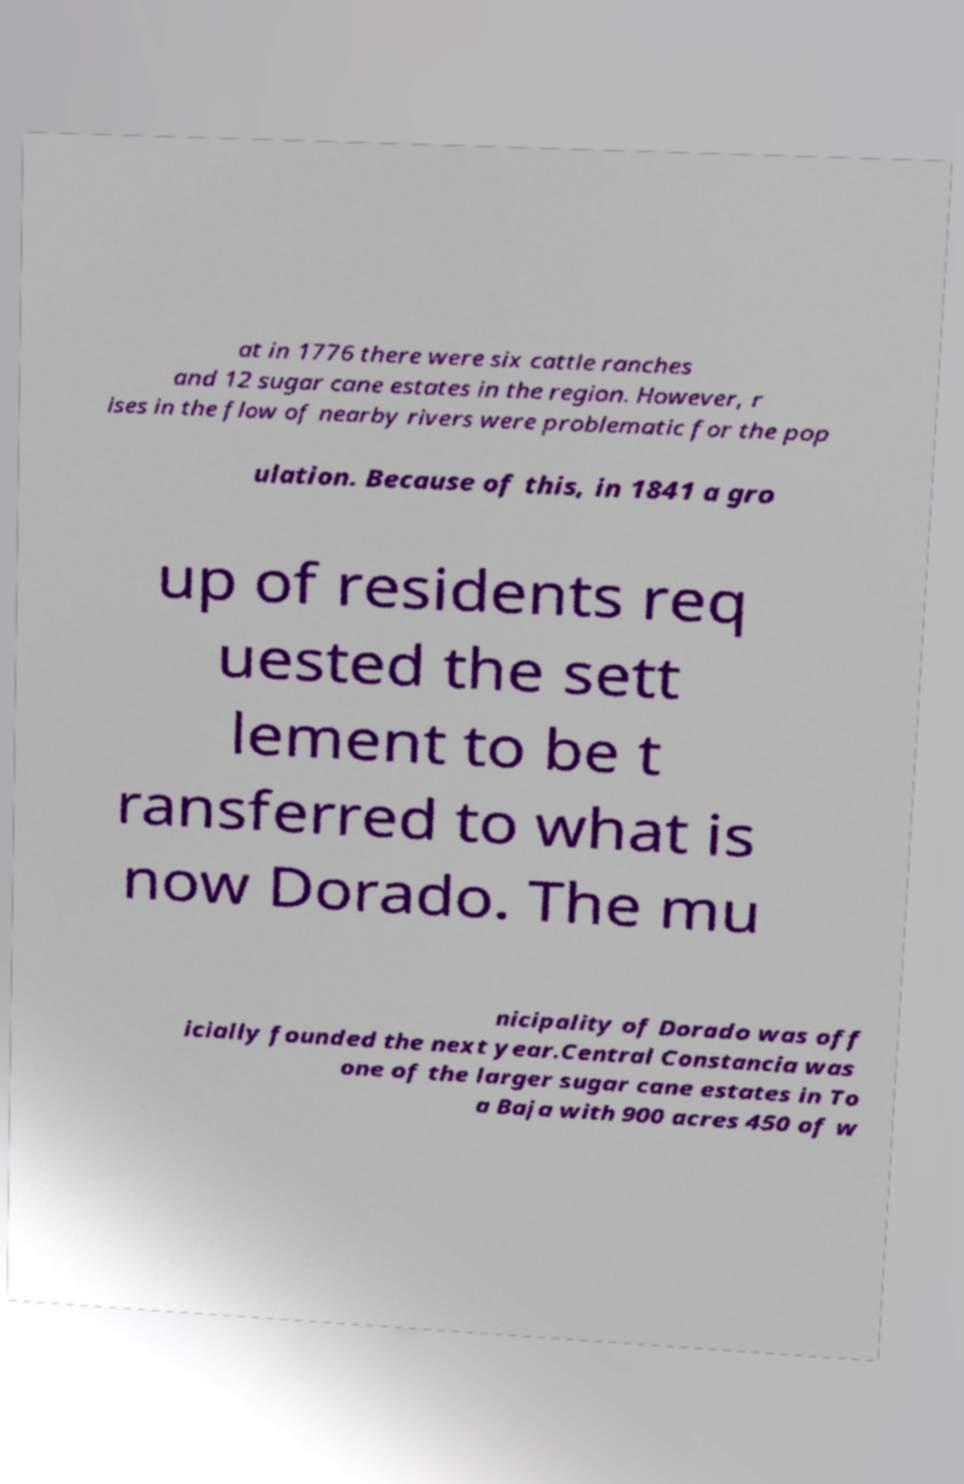I need the written content from this picture converted into text. Can you do that? at in 1776 there were six cattle ranches and 12 sugar cane estates in the region. However, r ises in the flow of nearby rivers were problematic for the pop ulation. Because of this, in 1841 a gro up of residents req uested the sett lement to be t ransferred to what is now Dorado. The mu nicipality of Dorado was off icially founded the next year.Central Constancia was one of the larger sugar cane estates in To a Baja with 900 acres 450 of w 